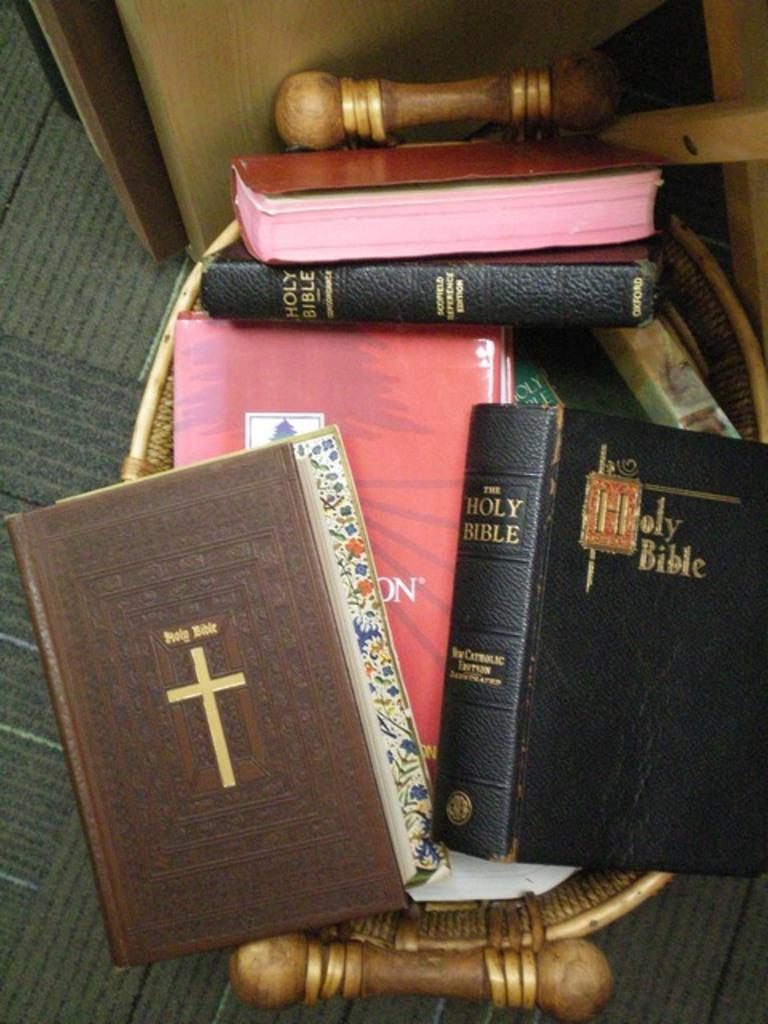Provide a one-sentence caption for the provided image. Multiple holy bible books stacked on top of each other. 